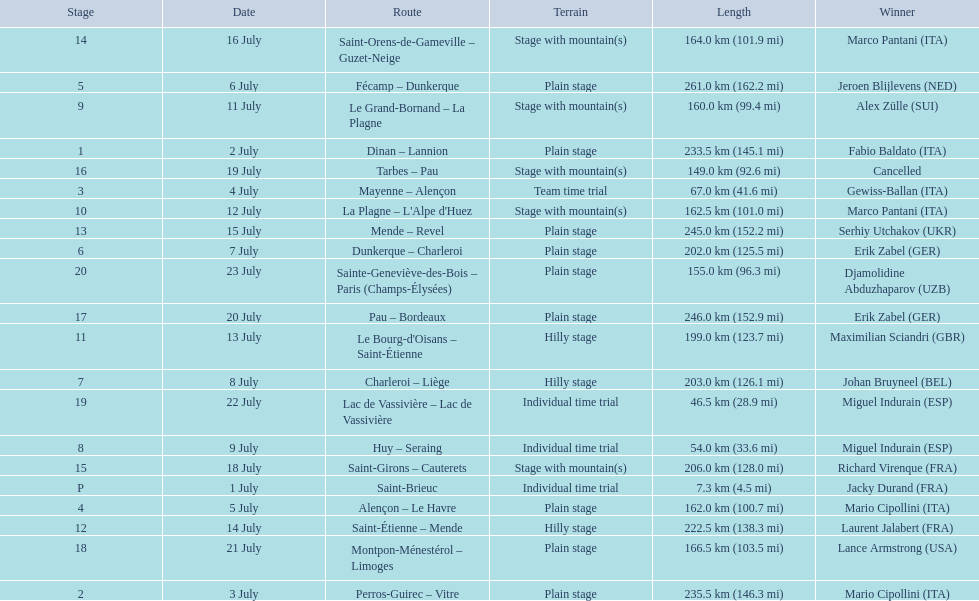What are the dates? 1 July, 2 July, 3 July, 4 July, 5 July, 6 July, 7 July, 8 July, 9 July, 11 July, 12 July, 13 July, 14 July, 15 July, 16 July, 18 July, 19 July, 20 July, 21 July, 22 July, 23 July. What is the length on 8 july? 203.0 km (126.1 mi). 